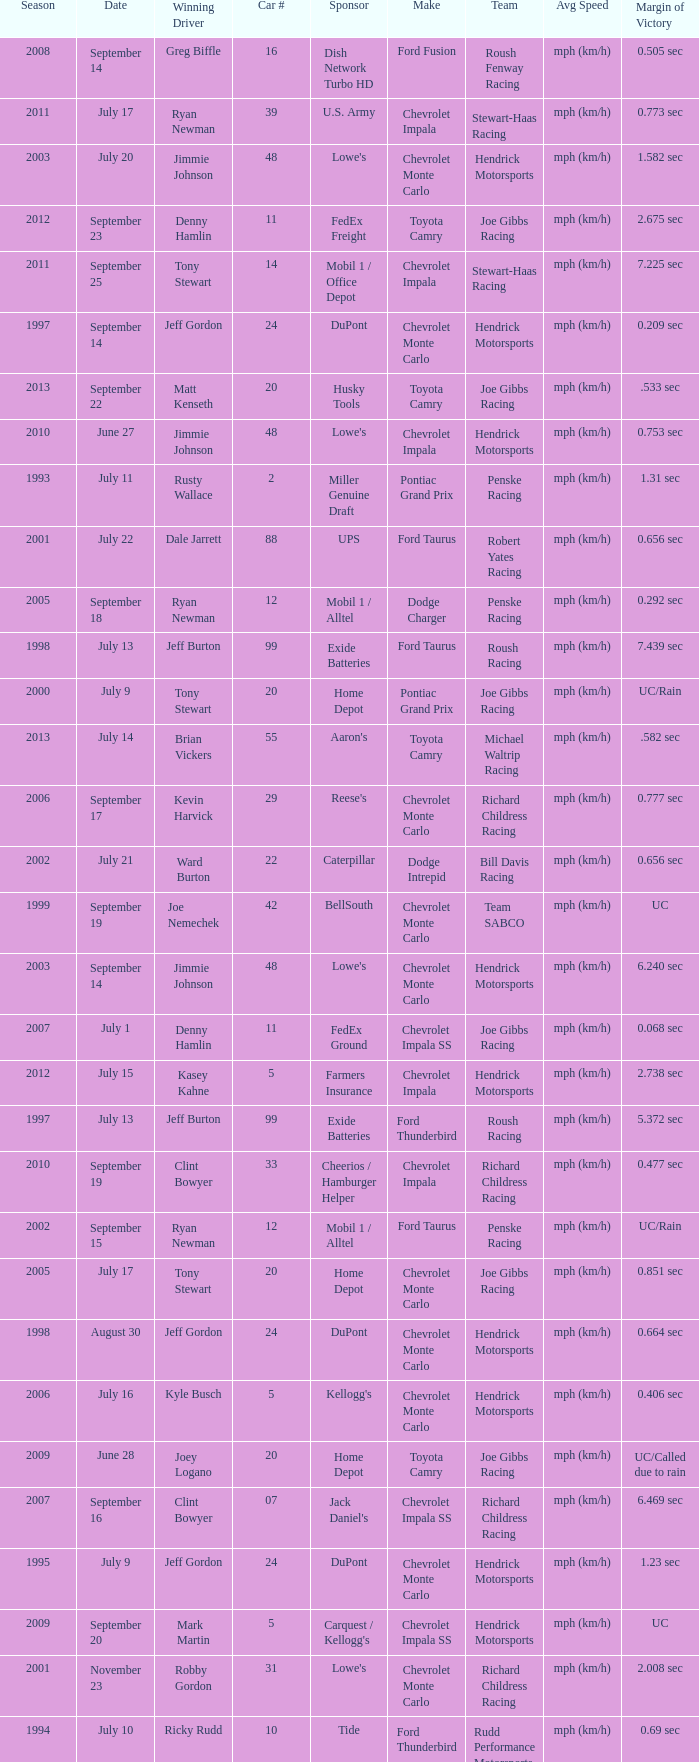What team ran car #24 on August 30? Hendrick Motorsports. 